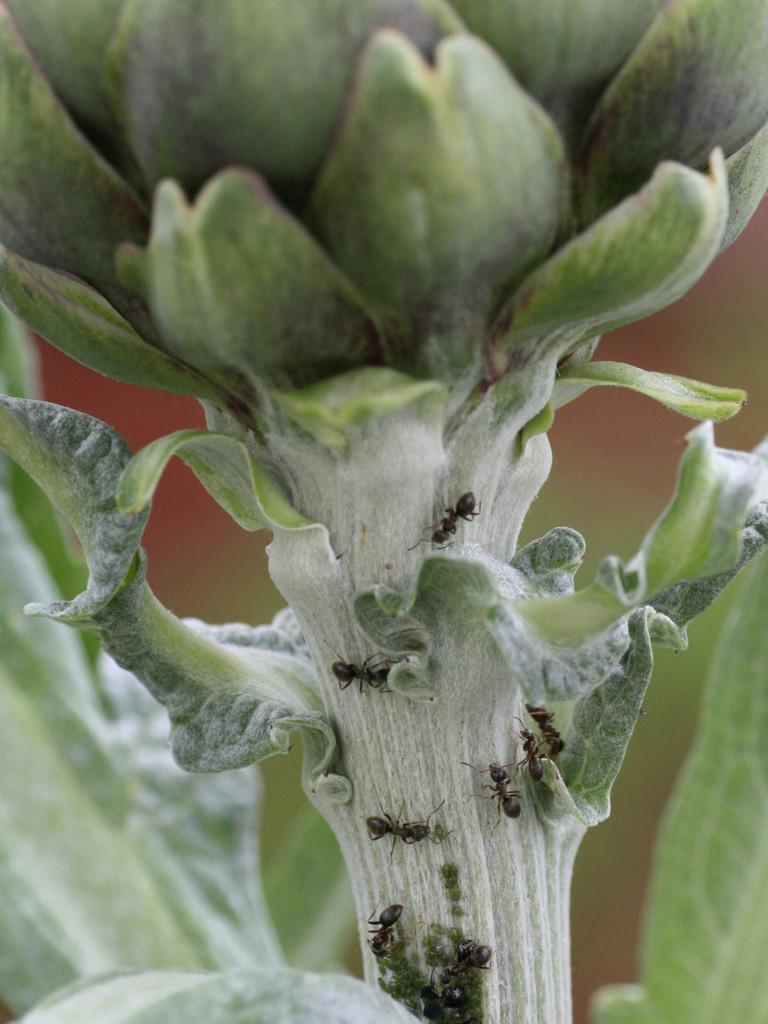What type of living organisms can be seen in the image? Plants can be seen in the image. Where are the plants located? The plants are on a surface. What other creatures can be seen on the plants? Black ants can be seen on the plant stem. What type of advice can be seen written on the leaves of the plants in the image? There is no advice written on the leaves of the plants in the image; the image only shows plants and black ants on the plant stem. 